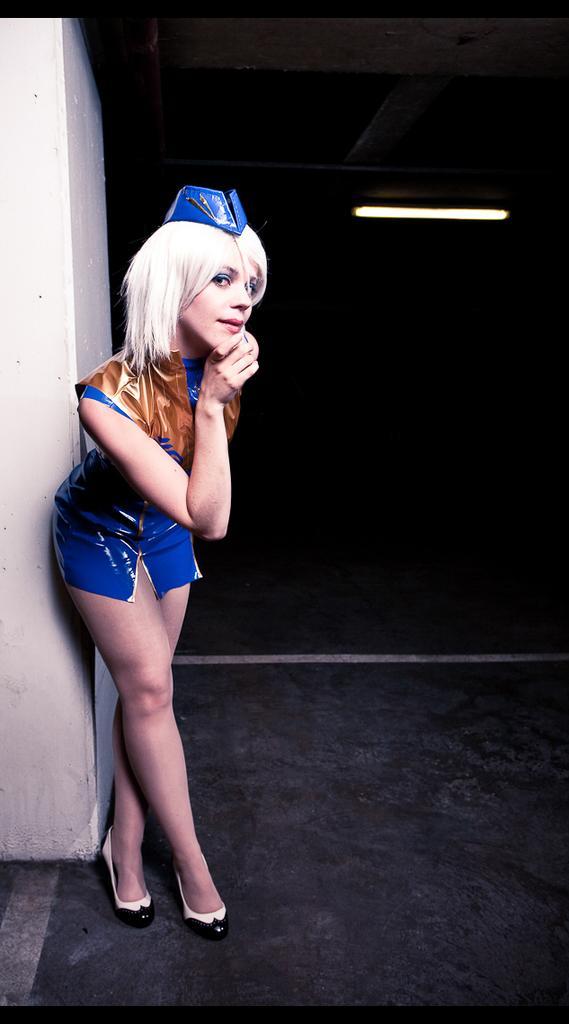How would you summarize this image in a sentence or two? In this image in the foreground there is one woman standing and in the background there is wall, light and there is a black background. At the bottom there is floor. 